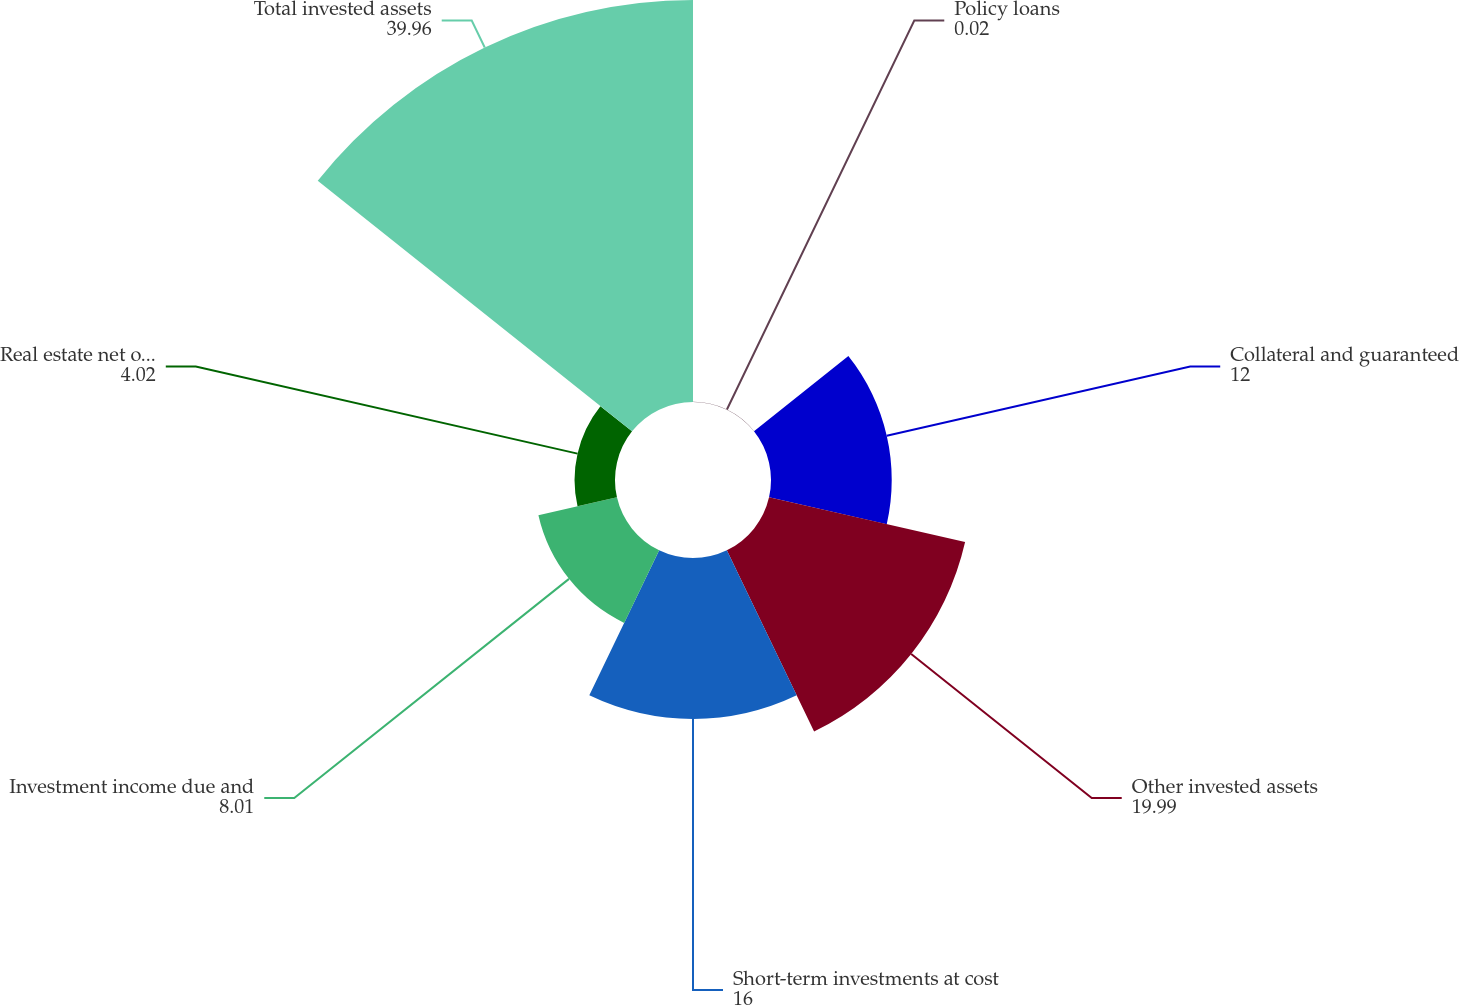Convert chart to OTSL. <chart><loc_0><loc_0><loc_500><loc_500><pie_chart><fcel>Policy loans<fcel>Collateral and guaranteed<fcel>Other invested assets<fcel>Short-term investments at cost<fcel>Investment income due and<fcel>Real estate net of accumulated<fcel>Total invested assets<nl><fcel>0.02%<fcel>12.0%<fcel>19.99%<fcel>16.0%<fcel>8.01%<fcel>4.02%<fcel>39.96%<nl></chart> 